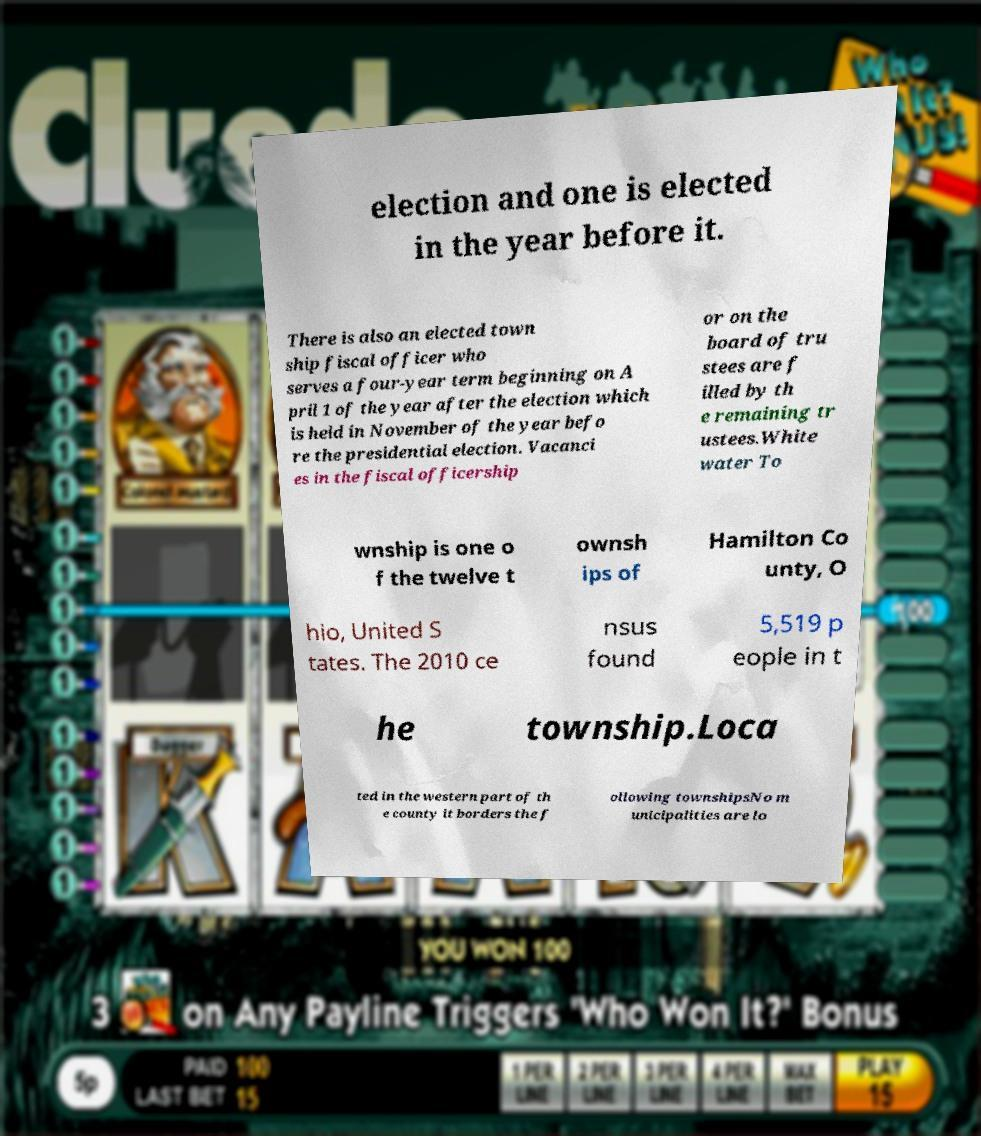I need the written content from this picture converted into text. Can you do that? election and one is elected in the year before it. There is also an elected town ship fiscal officer who serves a four-year term beginning on A pril 1 of the year after the election which is held in November of the year befo re the presidential election. Vacanci es in the fiscal officership or on the board of tru stees are f illed by th e remaining tr ustees.White water To wnship is one o f the twelve t ownsh ips of Hamilton Co unty, O hio, United S tates. The 2010 ce nsus found 5,519 p eople in t he township.Loca ted in the western part of th e county it borders the f ollowing townshipsNo m unicipalities are lo 